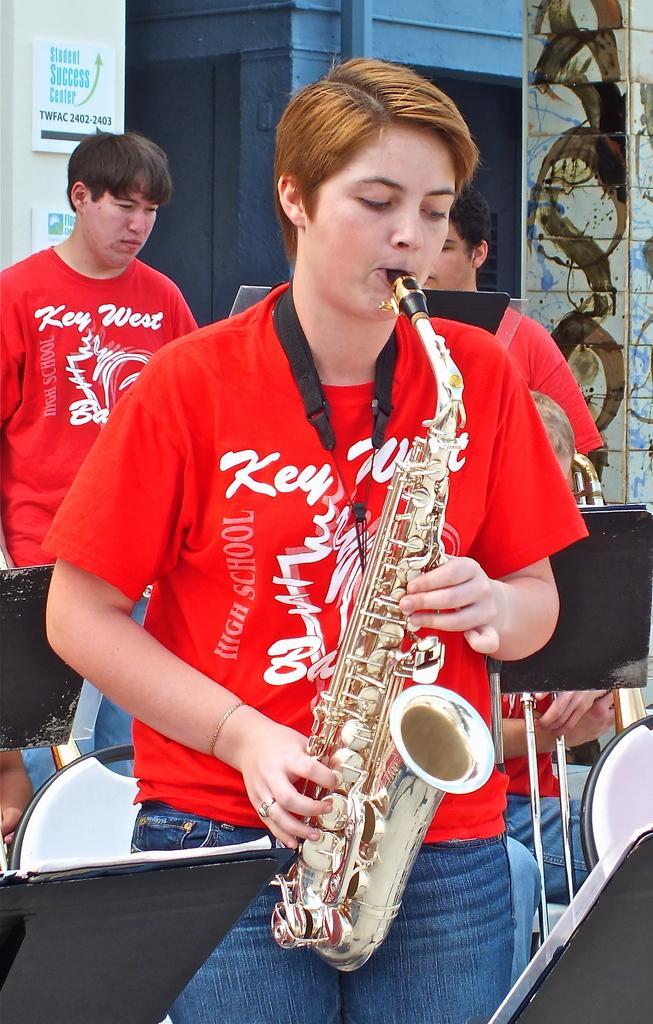Could you give a brief overview of what you see in this image? In this picture there is a person standing and playing musical instrument. At the back there are two persons standing and there is a person sitting and there are chairs and stands. At the back there is a building and there are boards and there is a pipe on the wall and there is text on the boards. 